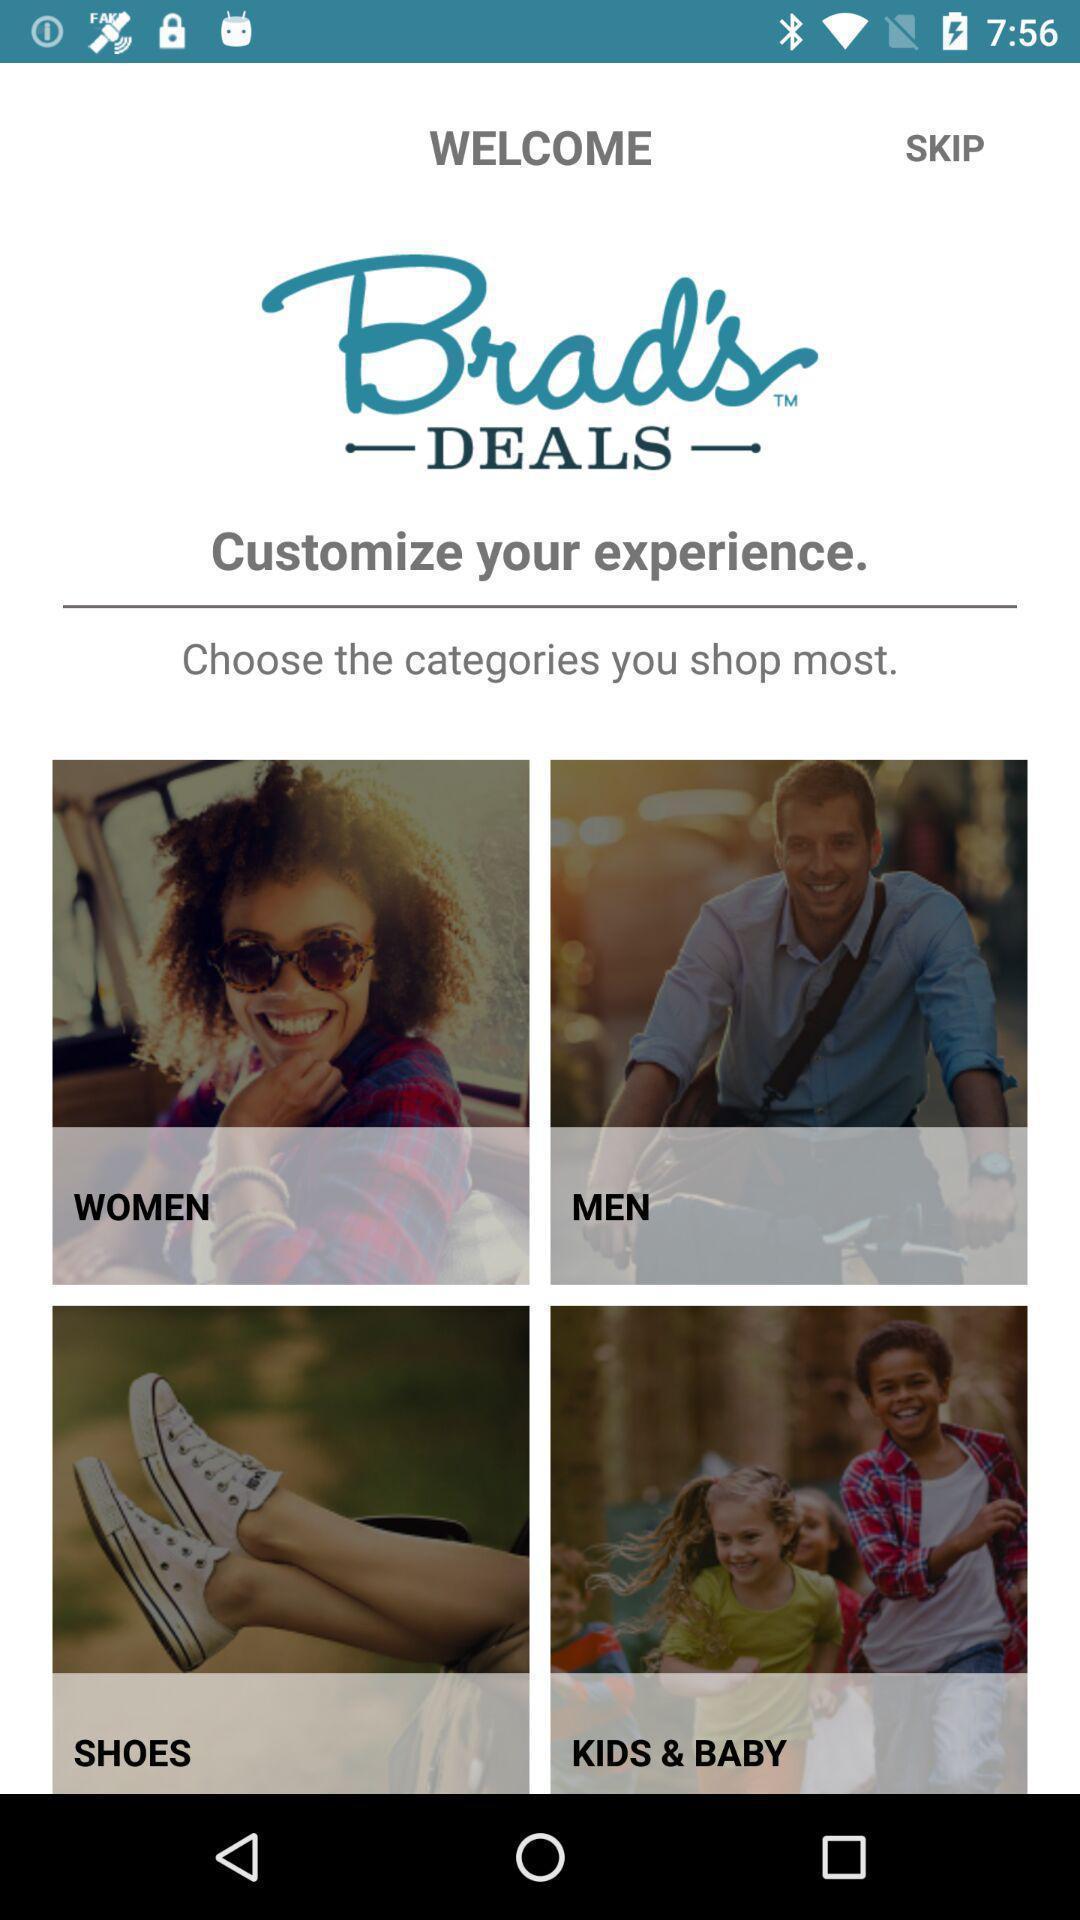Explain what's happening in this screen capture. Welcome page of an shopping app. 